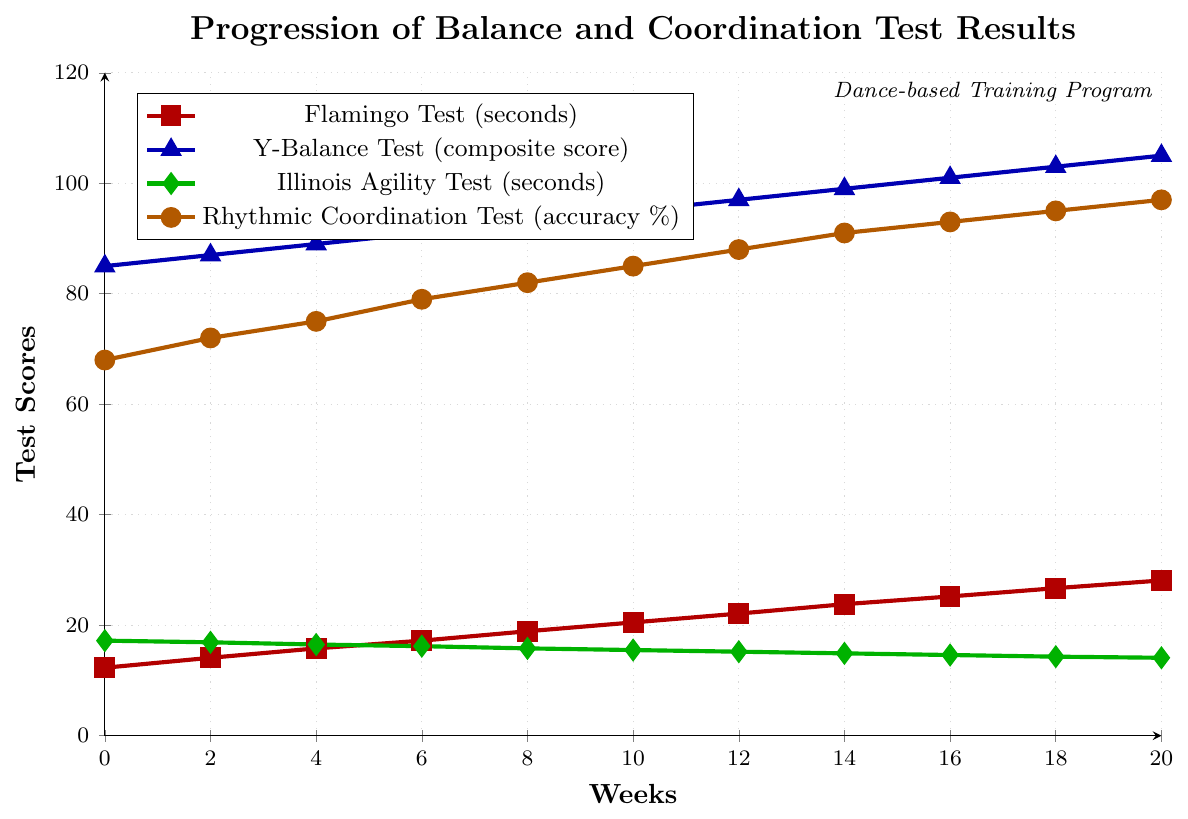How does the Flamingo Test score change from week 0 to week 20? The Flamingo Test score starts at 12.3 seconds in week 0 and increases to 28.1 seconds in week 20, showing a steady improvement over time.
Answer: It increases How do the Y-Balance Test and Rhythmic Coordination Test compare in terms of improvement by week 10? By week 10, the Y-Balance Test score improves from 85 to 95 (an increase of 10 points), while the Rhythmic Coordination Test score improves from 68% to 85% (an increase of 17 percentage points).
Answer: Rhythmic Coordination Test improved more Which test shows the most rapid improvement between weeks 10 and 12? Between weeks 10 and 12, the Flamingo Test went from 20.5 to 22.1 seconds (an increase of 1.6 seconds), the Y-Balance Test from 95 to 97 (an increase of 2), the Illinois Agility Test from 15.5 to 15.2 seconds (a decrease of 0.3 seconds), and the Rhythmic Coordination Test from 85% to 88% (an increase of 3%).
Answer: Rhythmic Coordination Test By how much does the Illinois Agility Test score change between week 0 and week 20? The Illinois Agility Test score decreases from 17.2 seconds in week 0 to 14.1 seconds in week 20. The total change is 17.2 - 14.1 = 3.1 seconds.
Answer: 3.1 seconds decrease At which week do all test scores show a consistent pattern of improvement without any drop? From week 0 to week 20, all test scores consistently improve without any drops at any week. The scores all increase steadily.
Answer: All weeks Which test results exhibit the largest percentage improvement from week 0 to week 20? The Flamingo Test improves from 12.3 to 28.1 seconds (128.46% improvement), the Y-Balance Test from 85 to 105 (23.53%), the Illinois Agility Test from 17.2 to 14.1 seconds (an improvement of 18.02% decrease), and the Rhythmic Coordination Test from 68% to 97% (42.65%). The largest improvement is seen in the Flamingo Test with a 128.46% increase.
Answer: Flamingo Test Which two tests show almost parallel improvement trends over weeks 0 to 20? The Y-Balance Test and Rhythmic Coordination Test show similar parallel improvement trends; the lines for both tests steadily rise, maintaining a consistent distance between them over the weeks.
Answer: Y-Balance Test and Rhythmic Coordination Test Is there any week where the Illinois Agility Test shows a plateau or minimal change in results? The Illinois Agility Test shows a minimal change in the early weeks, particularly between weeks 12 and 14, where it changes from 15.2 to 14.9 seconds, a very slight change.
Answer: Yes, weeks 12 to 14 How does the Rhythmic Coordination Test's accuracy percentage at week 16 compare to its accuracy percentage at week 8? At week 16, the Rhythmic Coordination Test's accuracy is 93%, compared to 82% at week 8. The score improves by 93 - 82 = 11%.
Answer: Improved by 11% 